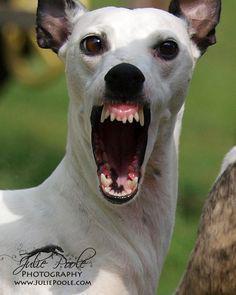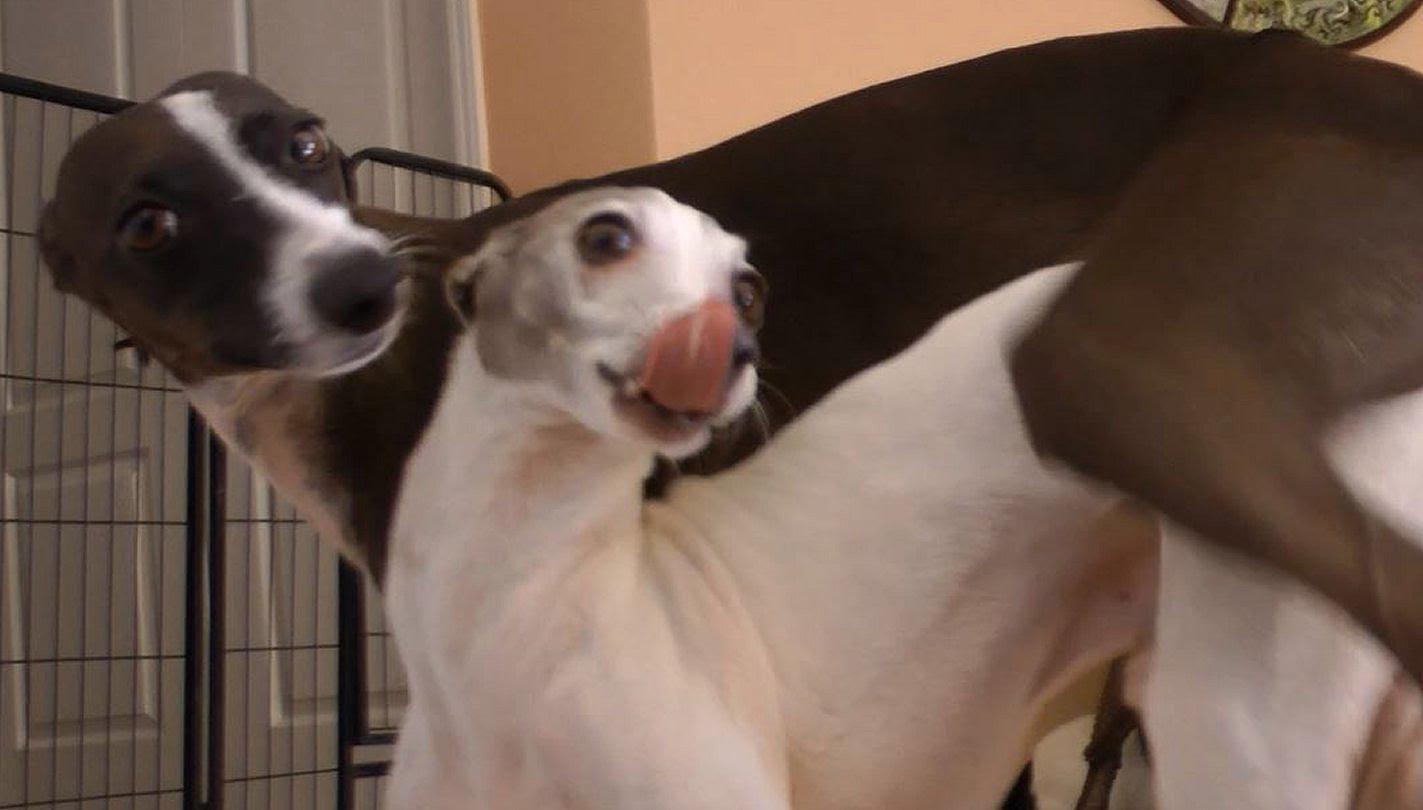The first image is the image on the left, the second image is the image on the right. Considering the images on both sides, is "a dog has it's tongue sticking out" valid? Answer yes or no. Yes. 